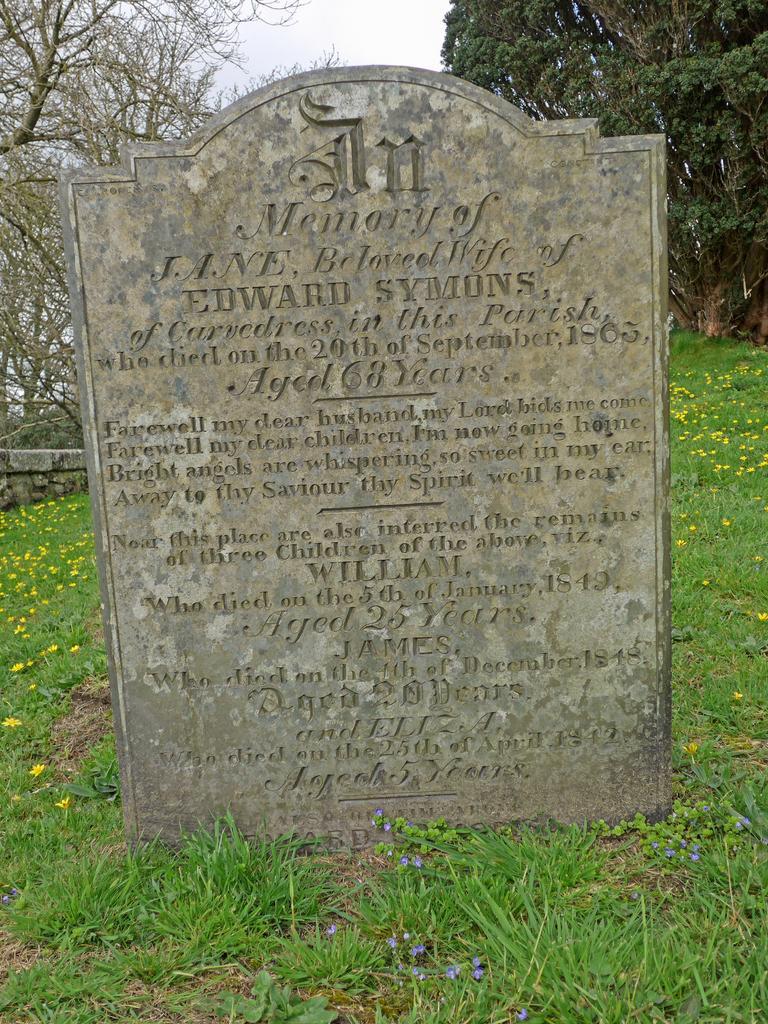In one or two sentences, can you explain what this image depicts? In the center of the image we can see one headstone. On the headstone, we can see some text. In the background, we can see the sky, clouds, trees, grass, flowers and a few other objects. 